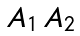Convert formula to latex. <formula><loc_0><loc_0><loc_500><loc_500>\begin{matrix} A _ { 1 } \, A _ { 2 } \end{matrix}</formula> 